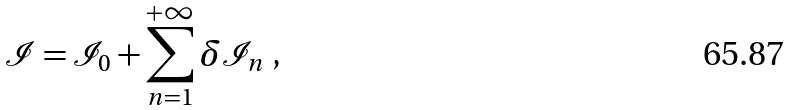<formula> <loc_0><loc_0><loc_500><loc_500>\mathcal { I } = \mathcal { I } _ { 0 } + \sum _ { n = 1 } ^ { + \infty } \delta \mathcal { I } _ { n } \ ,</formula> 